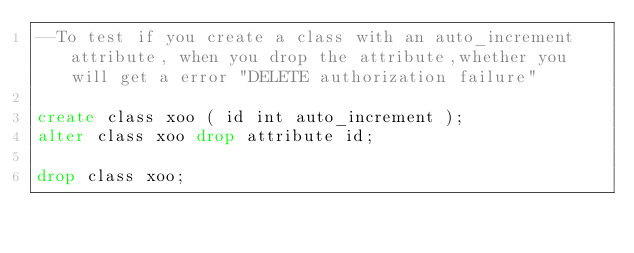Convert code to text. <code><loc_0><loc_0><loc_500><loc_500><_SQL_>--To test if you create a class with an auto_increment attribute, when you drop the attribute,whether you will get a error "DELETE authorization failure"

create class xoo ( id int auto_increment );
alter class xoo drop attribute id;

drop class xoo;</code> 